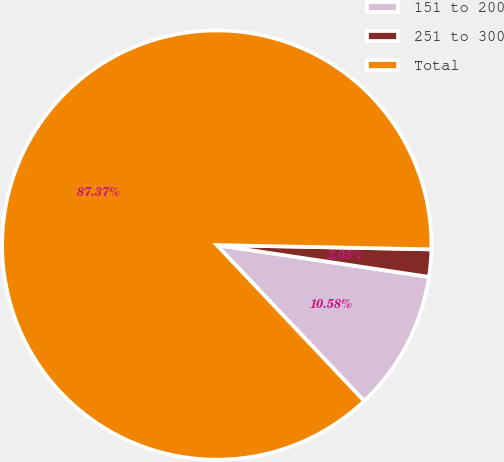Convert chart. <chart><loc_0><loc_0><loc_500><loc_500><pie_chart><fcel>151 to 200<fcel>251 to 300<fcel>Total<nl><fcel>10.58%<fcel>2.05%<fcel>87.37%<nl></chart> 